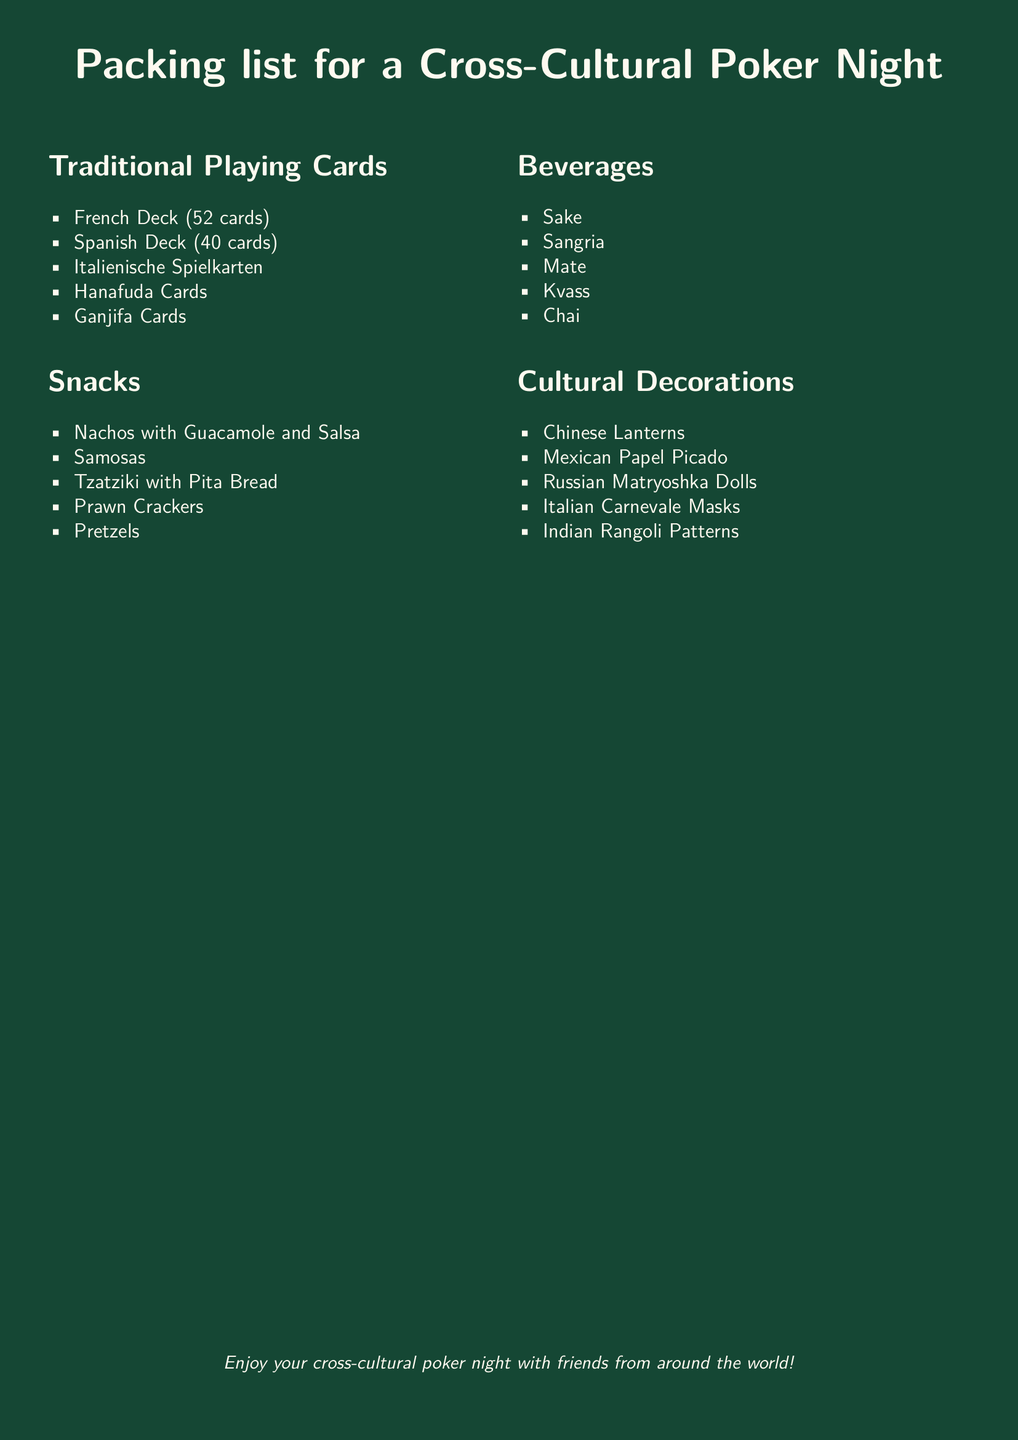What types of playing cards are included? The document lists several types of traditional playing cards under the "Traditional Playing Cards" section, including French, Spanish, Italian, Hanafuda, and Ganjifa cards.
Answer: French Deck, Spanish Deck, Italianische Spielkarten, Hanafuda Cards, Ganjifa Cards How many snacks are mentioned in the list? The snacks section contains a total of five different snacks listed explicitly in the document.
Answer: 5 What is one beverage from the list? The beverages section includes various drinks, and the example of Sake is referenced specifically.
Answer: Sake Which cultural decoration features from Mexico? The document mentions "Mexican Papel Picado" as one of the cultural decorations.
Answer: Mexican Papel Picado Which snack is good for dipping? Among the snacks listed, Nachos with Guacamole and Salsa is explicitly suggested as a dipping snack.
Answer: Nachos with Guacamole and Salsa What type of games can be played with Hanafuda cards? Hanafuda cards are traditionally used for Japanese games, notable for their distinct pattern cards.
Answer: Japanese games What is the significance of Rangoli patterns? The Rangoli patterns are traditionally used in Indian festivals, adding cultural significance to decorations.
Answer: Indian festivals How many types of beverages are listed? The beverages section includes a total of five different types.
Answer: 5 